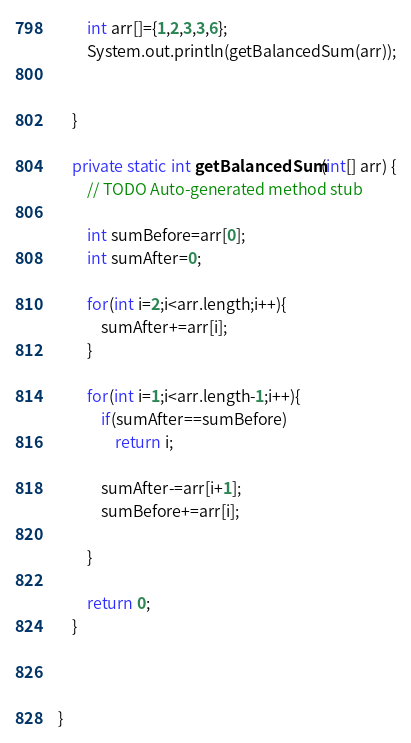<code> <loc_0><loc_0><loc_500><loc_500><_Java_>		int arr[]={1,2,3,3,6};
		System.out.println(getBalancedSum(arr));
		
		
	}

	private static int getBalancedSum(int[] arr) {
		// TODO Auto-generated method stub
		
		int sumBefore=arr[0];
		int sumAfter=0;
		
		for(int i=2;i<arr.length;i++){
			sumAfter+=arr[i];
		}
		
		for(int i=1;i<arr.length-1;i++){
			if(sumAfter==sumBefore)
				return i;
			
			sumAfter-=arr[i+1];
			sumBefore+=arr[i];
			
		}
		
		return 0;
	}
	
	

}
</code> 